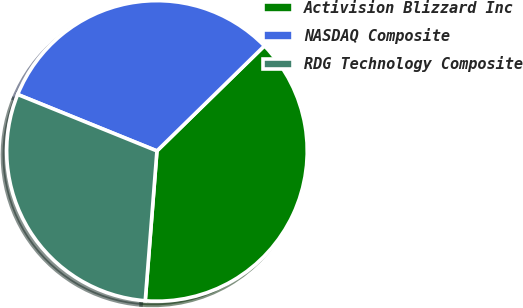<chart> <loc_0><loc_0><loc_500><loc_500><pie_chart><fcel>Activision Blizzard Inc<fcel>NASDAQ Composite<fcel>RDG Technology Composite<nl><fcel>38.56%<fcel>31.55%<fcel>29.89%<nl></chart> 